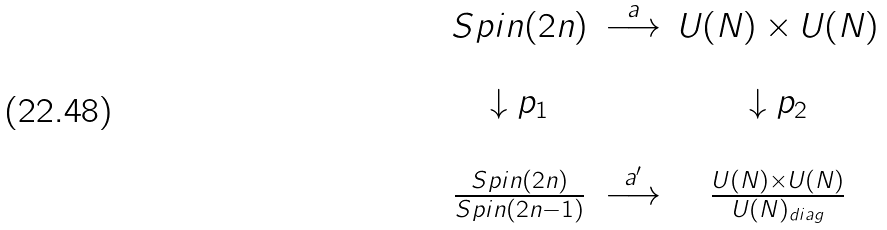<formula> <loc_0><loc_0><loc_500><loc_500>\begin{array} { c c c } S p i n ( 2 n ) & \stackrel { a } { \longrightarrow } & U ( N ) \times U ( N ) \\ & & \\ \downarrow p _ { 1 } & & \downarrow p _ { 2 } \\ & & \\ \frac { S p i n ( 2 n ) } { S p i n ( 2 n - 1 ) } & \stackrel { a ^ { \prime } } { \longrightarrow } & \frac { U ( N ) \times U ( N ) } { U ( N ) _ { d i a g } } \end{array}</formula> 